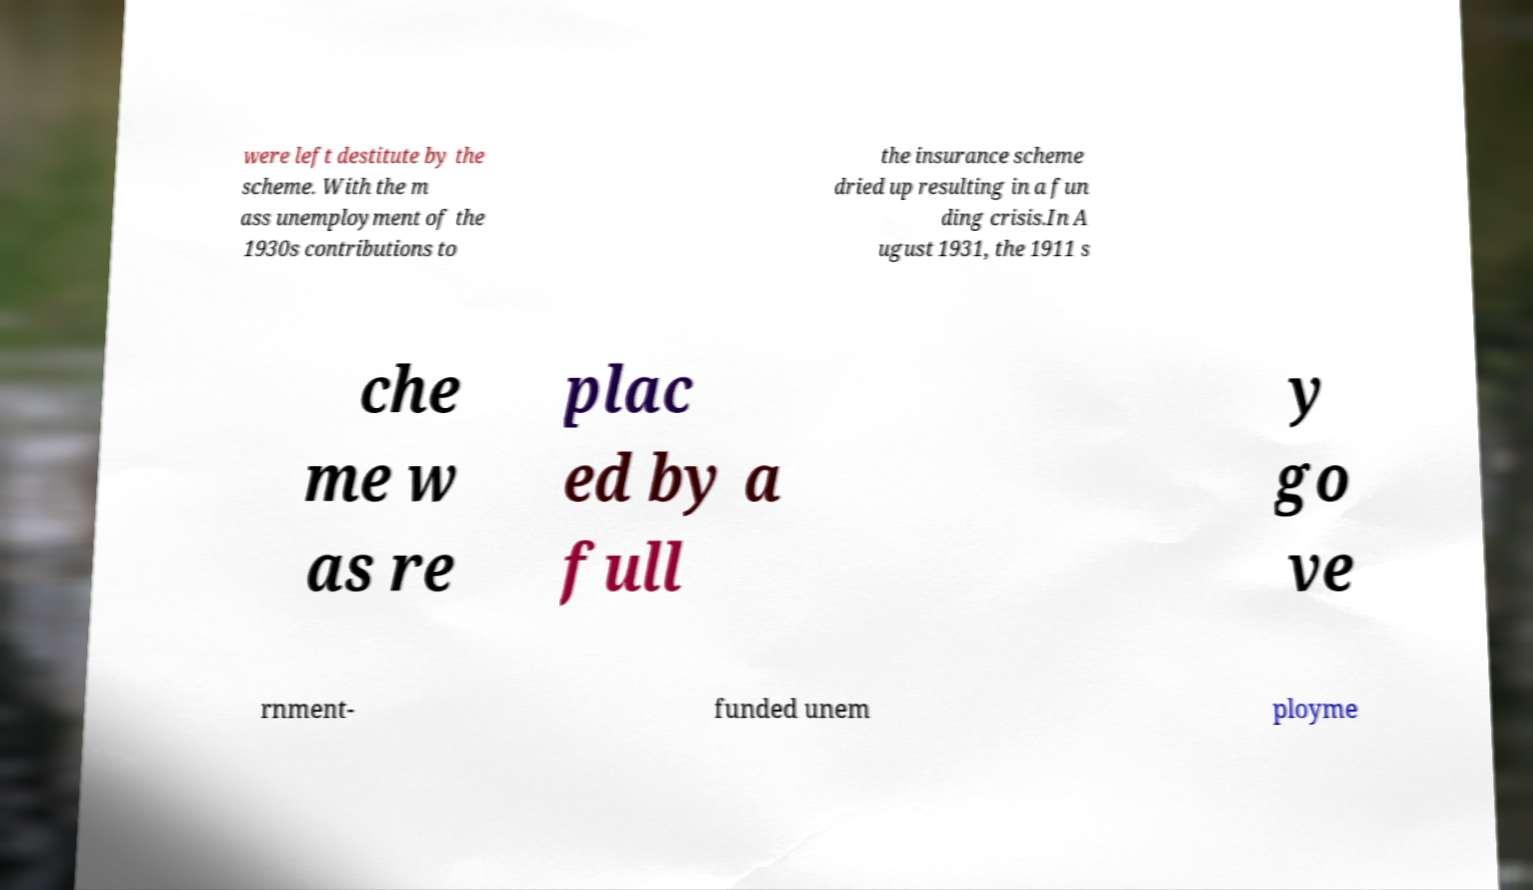What messages or text are displayed in this image? I need them in a readable, typed format. were left destitute by the scheme. With the m ass unemployment of the 1930s contributions to the insurance scheme dried up resulting in a fun ding crisis.In A ugust 1931, the 1911 s che me w as re plac ed by a full y go ve rnment- funded unem ployme 